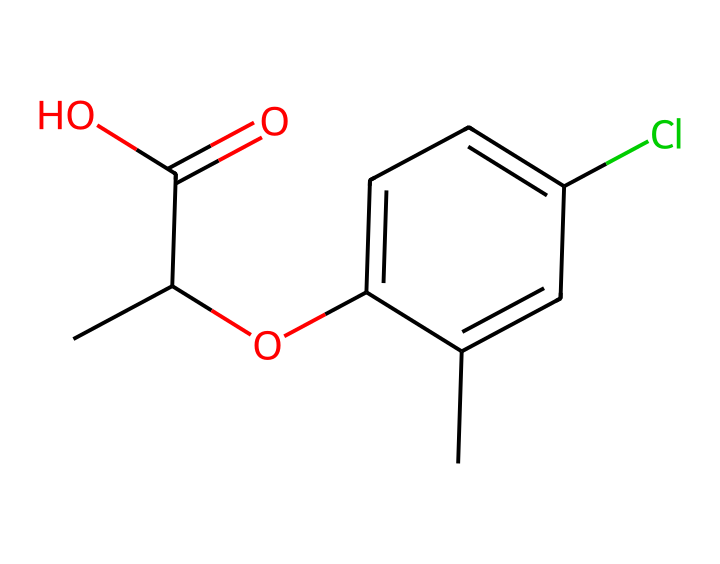What is the molecular formula of this chemical? By interpreting the SMILES notation, we identify the constituent atoms: there are 10 carbon (C) atoms, 10 hydrogen (H) atoms, 2 oxygen (O) atoms, and 1 chlorine (Cl) atom. Thus, the molecular formula is C10H10ClO2.
Answer: C10H10ClO2 How many carbon atoms are present in mecoprop? The structure can be deduced from the SMILES representation, which reveals 10 carbon atoms (C). Counting them confirms this number.
Answer: 10 What functional groups are present in mecoprop? Analyzing the SMILES string indicates the presence of a carboxylic acid group (C(=O)O) and a methoxy group (O) connected to the aromatic ring, which serves as the functional groups.
Answer: carboxylic acid and methoxy group What is the significance of the chlorine atom in mecoprop? The chlorine atom in the structure is attached to the aromatic ring and plays a role in enhancing the herbicidal activity by affecting the compound's reactivity and stability.
Answer: enhances herbicidal activity How does the structure of mecoprop classify it as a herbicide? The presence of the carboxylic acid group combined with the aromatic ring structure is typical for herbicides, allowing the chemical to disrupt plant growth by mimicking natural plant hormones (auxins).
Answer: disrupts plant growth What is the aromatic ring in mecoprop composed of? The SMILES representation shows a benzene-like structure, which is characterized by a 6-membered carbon ring with alternating double bonds, confirming the presence of an aromatic ring.
Answer: benzene-like structure 